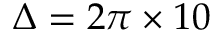Convert formula to latex. <formula><loc_0><loc_0><loc_500><loc_500>\Delta = 2 \pi \times 1 0</formula> 